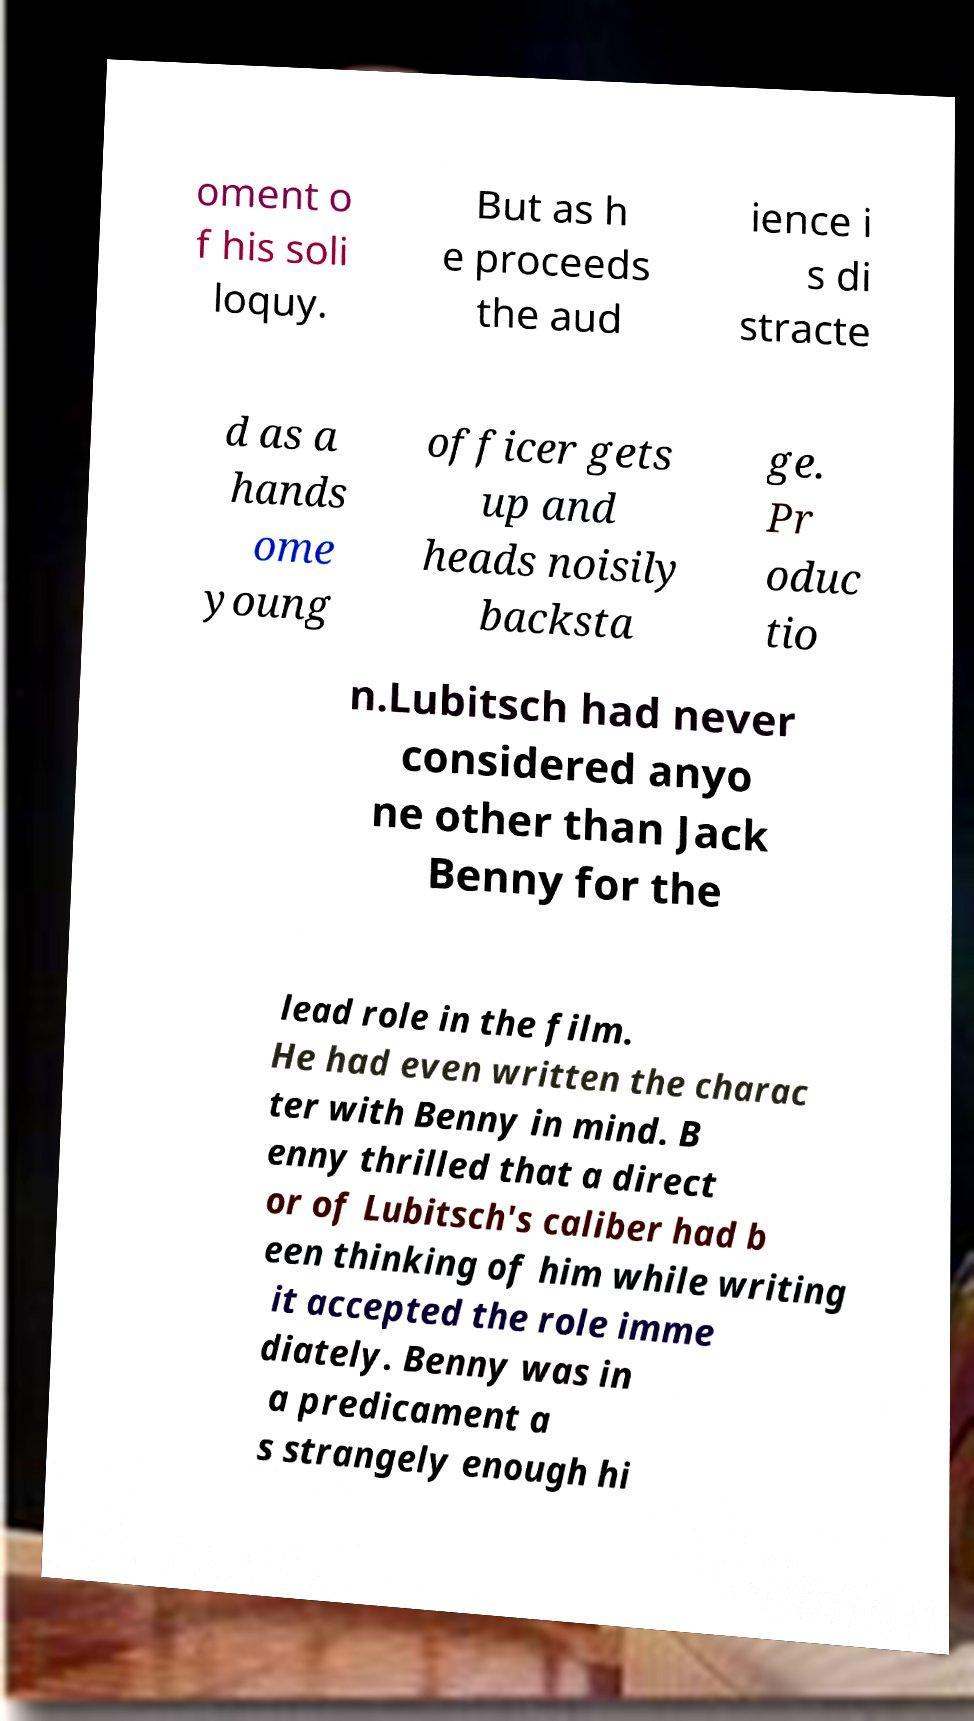Can you read and provide the text displayed in the image?This photo seems to have some interesting text. Can you extract and type it out for me? oment o f his soli loquy. But as h e proceeds the aud ience i s di stracte d as a hands ome young officer gets up and heads noisily backsta ge. Pr oduc tio n.Lubitsch had never considered anyo ne other than Jack Benny for the lead role in the film. He had even written the charac ter with Benny in mind. B enny thrilled that a direct or of Lubitsch's caliber had b een thinking of him while writing it accepted the role imme diately. Benny was in a predicament a s strangely enough hi 